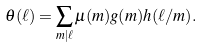<formula> <loc_0><loc_0><loc_500><loc_500>\theta ( \ell ) = \sum _ { m | \ell } \mu ( m ) g ( m ) h ( \ell / m ) .</formula> 